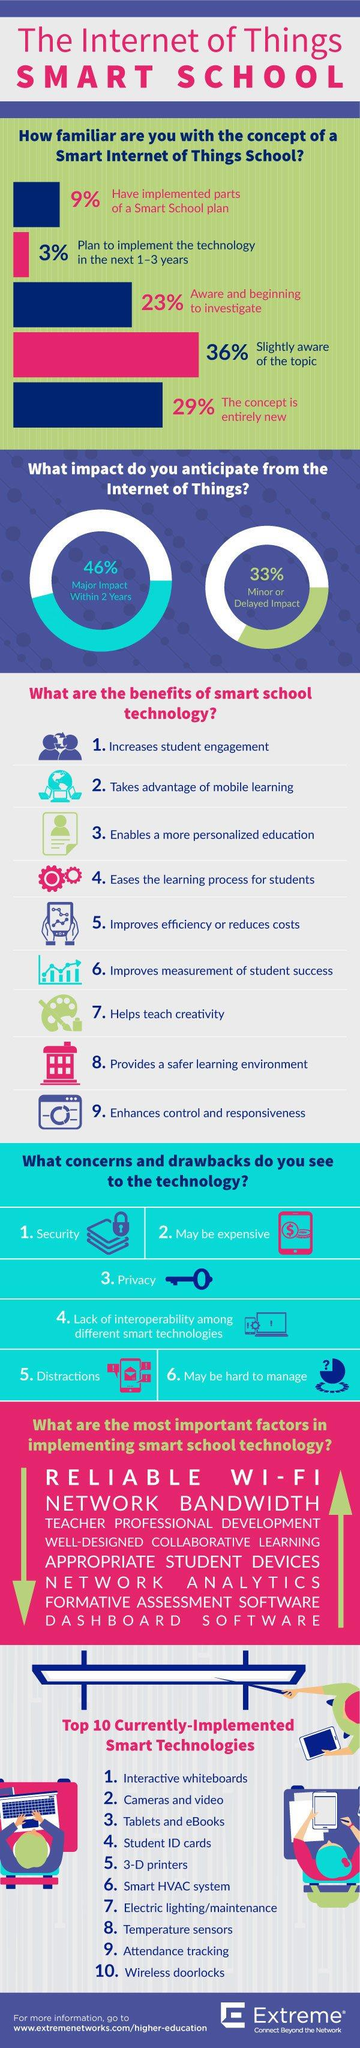List a handful of essential elements in this visual. Approximately 29% of individuals are not aware of the concept of Smart Internet of Things School. The paint brush and coloring palette are beneficial in teaching creativity. According to the survey, a total of 12% of the respondents have already implemented or plan to implement the technology in the next 1-3 years. According to a survey, 33% of people feel a minor or delayed impact from the Internet of Things. The key image conveys a concern related to privacy. 